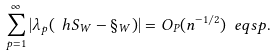Convert formula to latex. <formula><loc_0><loc_0><loc_500><loc_500>\sum _ { p = 1 } ^ { \infty } | \lambda _ { p } ( \ h S _ { W } - \S _ { W } ) | = O _ { P } ( n ^ { - 1 / 2 } ) \ e q s p .</formula> 